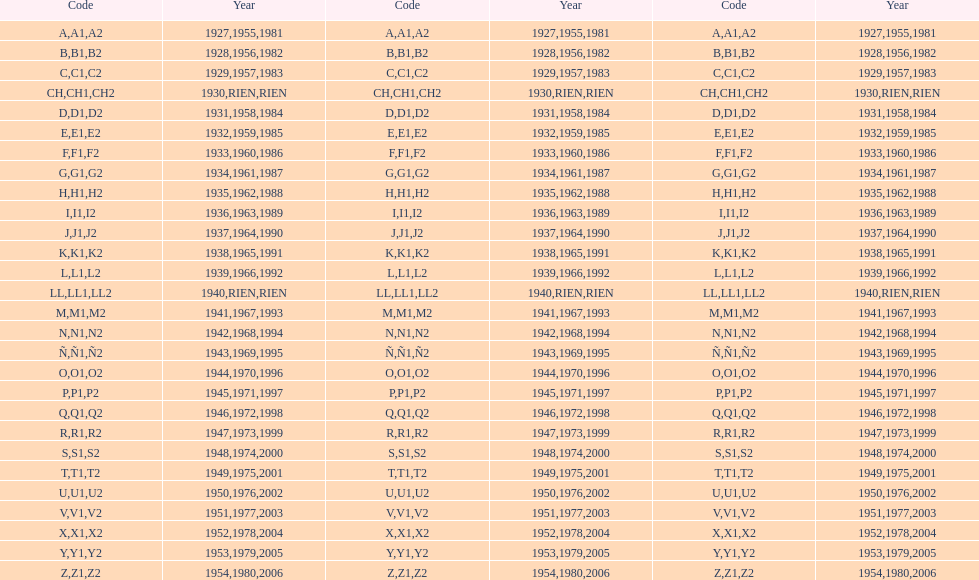Excluding 1927, when did the code have a starting letter of "a"? 1955, 1981. 